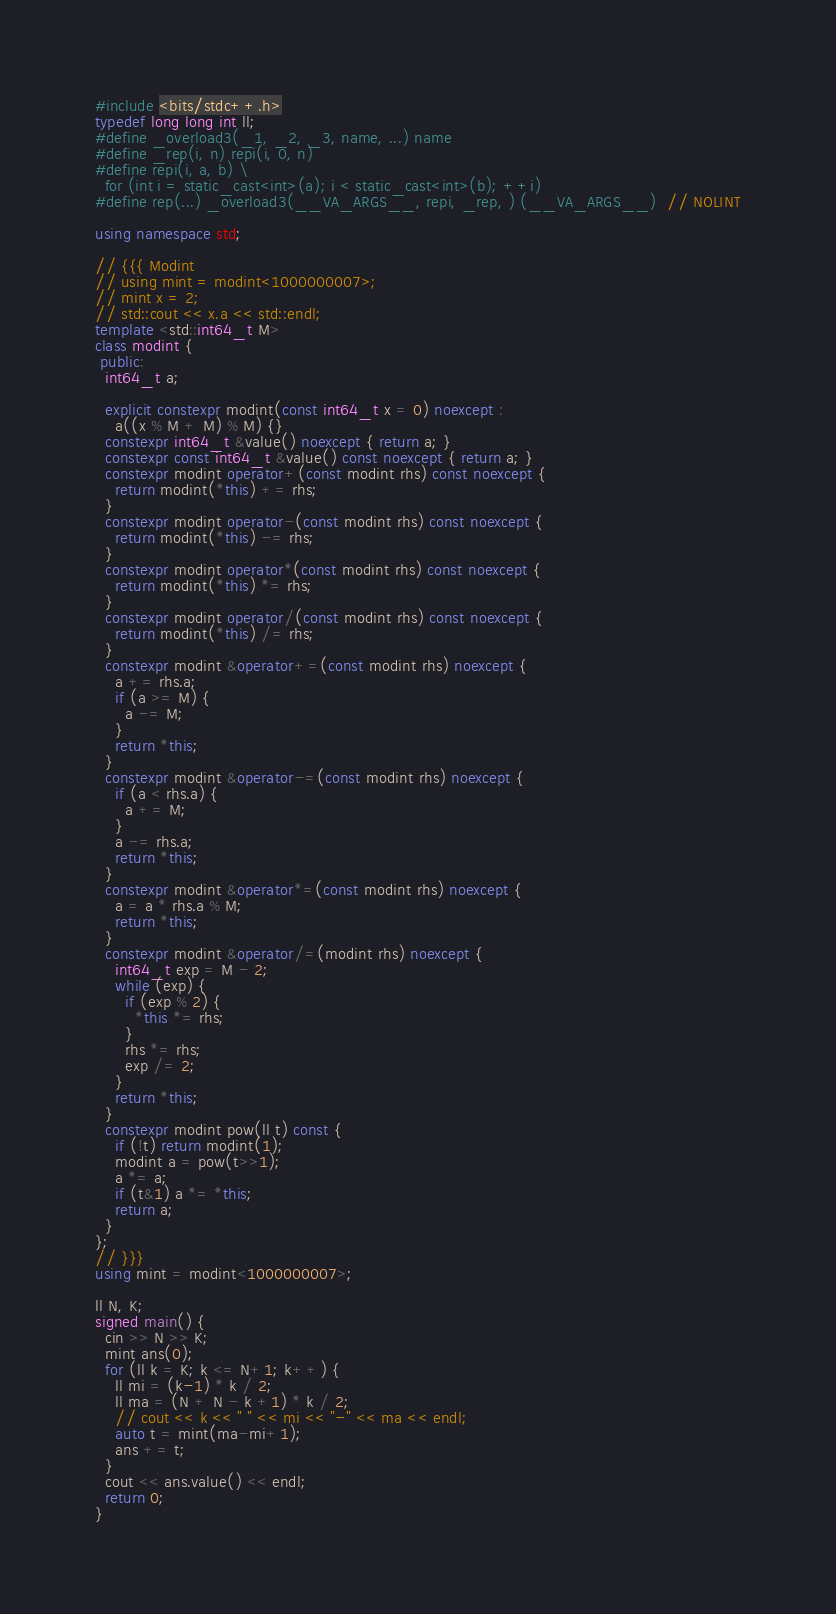<code> <loc_0><loc_0><loc_500><loc_500><_C++_>#include <bits/stdc++.h>
typedef long long int ll;
#define _overload3(_1, _2, _3, name, ...) name
#define _rep(i, n) repi(i, 0, n)
#define repi(i, a, b) \
  for (int i = static_cast<int>(a); i < static_cast<int>(b); ++i)
#define rep(...) _overload3(__VA_ARGS__, repi, _rep, ) (__VA_ARGS__)  // NOLINT
 
using namespace std;

// {{{ Modint
// using mint = modint<1000000007>;
// mint x = 2;
// std::cout << x.a << std::endl;
template <std::int64_t M>
class modint {
 public:
  int64_t a;

  explicit constexpr modint(const int64_t x = 0) noexcept :
    a((x % M + M) % M) {}
  constexpr int64_t &value() noexcept { return a; }
  constexpr const int64_t &value() const noexcept { return a; }
  constexpr modint operator+(const modint rhs) const noexcept {
    return modint(*this) += rhs;
  }
  constexpr modint operator-(const modint rhs) const noexcept {
    return modint(*this) -= rhs;
  }
  constexpr modint operator*(const modint rhs) const noexcept {
    return modint(*this) *= rhs;
  }
  constexpr modint operator/(const modint rhs) const noexcept {
    return modint(*this) /= rhs;
  }
  constexpr modint &operator+=(const modint rhs) noexcept {
    a += rhs.a;
    if (a >= M) {
      a -= M;
    }
    return *this;
  }
  constexpr modint &operator-=(const modint rhs) noexcept {
    if (a < rhs.a) {
      a += M;
    }
    a -= rhs.a;
    return *this;
  }
  constexpr modint &operator*=(const modint rhs) noexcept {
    a = a * rhs.a % M;
    return *this;
  }
  constexpr modint &operator/=(modint rhs) noexcept {
    int64_t exp = M - 2;
    while (exp) {
      if (exp % 2) {
        *this *= rhs;
      }
      rhs *= rhs;
      exp /= 2;
    }
    return *this;
  }
  constexpr modint pow(ll t) const {
    if (!t) return modint(1);
    modint a = pow(t>>1);
    a *= a;
    if (t&1) a *= *this;
    return a;
  }
};
// }}}
using mint = modint<1000000007>;

ll N, K;
signed main() {
  cin >> N >> K;
  mint ans(0);
  for (ll k = K; k <= N+1; k++) {
    ll mi = (k-1) * k / 2;
    ll ma = (N + N - k +1) * k / 2;
    // cout << k << " " << mi << "-" << ma << endl;
    auto t = mint(ma-mi+1);
    ans += t;
  }
  cout << ans.value() << endl;
  return 0;
}
</code> 